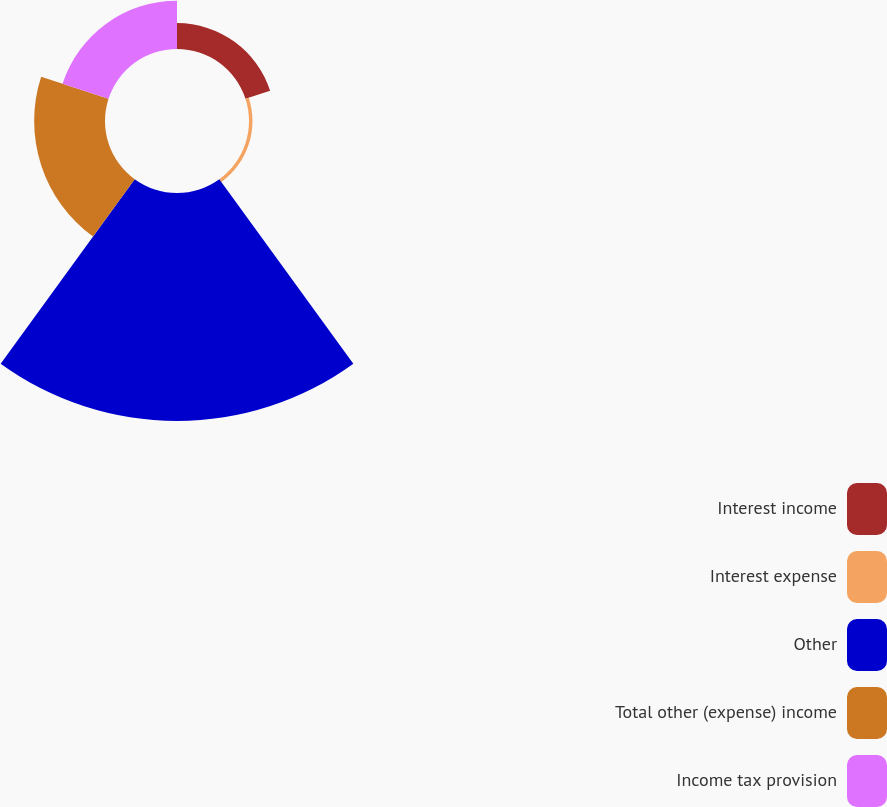<chart> <loc_0><loc_0><loc_500><loc_500><pie_chart><fcel>Interest income<fcel>Interest expense<fcel>Other<fcel>Total other (expense) income<fcel>Income tax provision<nl><fcel>6.88%<fcel>0.92%<fcel>60.55%<fcel>18.81%<fcel>12.84%<nl></chart> 